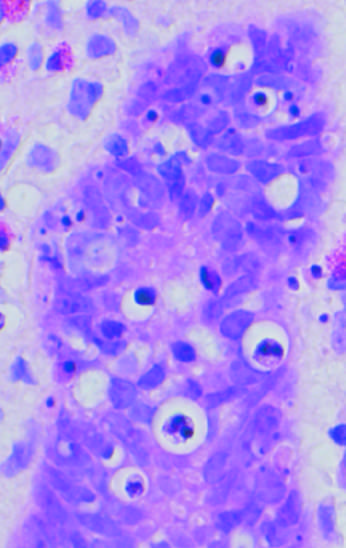re the areas of white chalky deposits shown?
Answer the question using a single word or phrase. No 